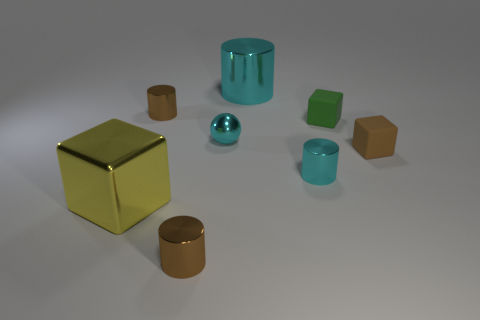Add 2 purple metal things. How many objects exist? 10 Subtract all cubes. How many objects are left? 5 Add 6 large yellow matte cylinders. How many large yellow matte cylinders exist? 6 Subtract 0 red cubes. How many objects are left? 8 Subtract all tiny brown objects. Subtract all cyan objects. How many objects are left? 2 Add 4 big cylinders. How many big cylinders are left? 5 